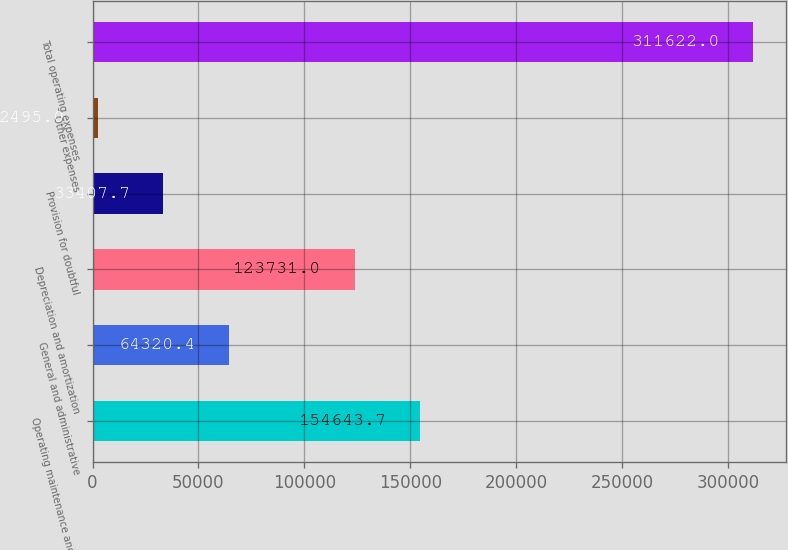<chart> <loc_0><loc_0><loc_500><loc_500><bar_chart><fcel>Operating maintenance and real<fcel>General and administrative<fcel>Depreciation and amortization<fcel>Provision for doubtful<fcel>Other expenses<fcel>Total operating expenses<nl><fcel>154644<fcel>64320.4<fcel>123731<fcel>33407.7<fcel>2495<fcel>311622<nl></chart> 